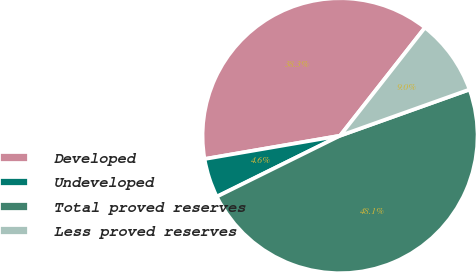Convert chart to OTSL. <chart><loc_0><loc_0><loc_500><loc_500><pie_chart><fcel>Developed<fcel>Undeveloped<fcel>Total proved reserves<fcel>Less proved reserves<nl><fcel>38.3%<fcel>4.6%<fcel>48.14%<fcel>8.95%<nl></chart> 